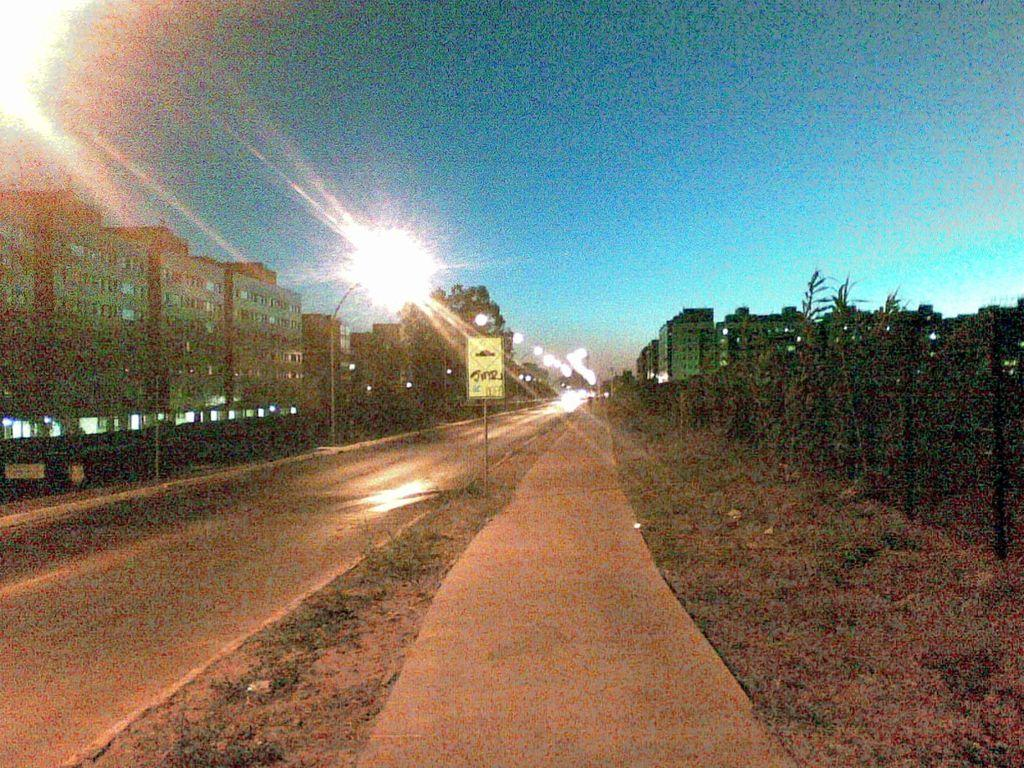What is the main feature of the image? There is a road in the image. What is attached to the pole in the image? There is a board attached to the pole in the image. What can be seen in the distance in the image? There are buildings in the background of the image. What is providing illumination in the image? There are lights visible in the image. What is visible in the sky in the image? The sky is visible in the background of the image. What type of songs can be heard coming from the buildings in the image? There is no indication of any songs or sounds coming from the buildings in the image, so it's not possible to determine what, if any, songs might be heard. 